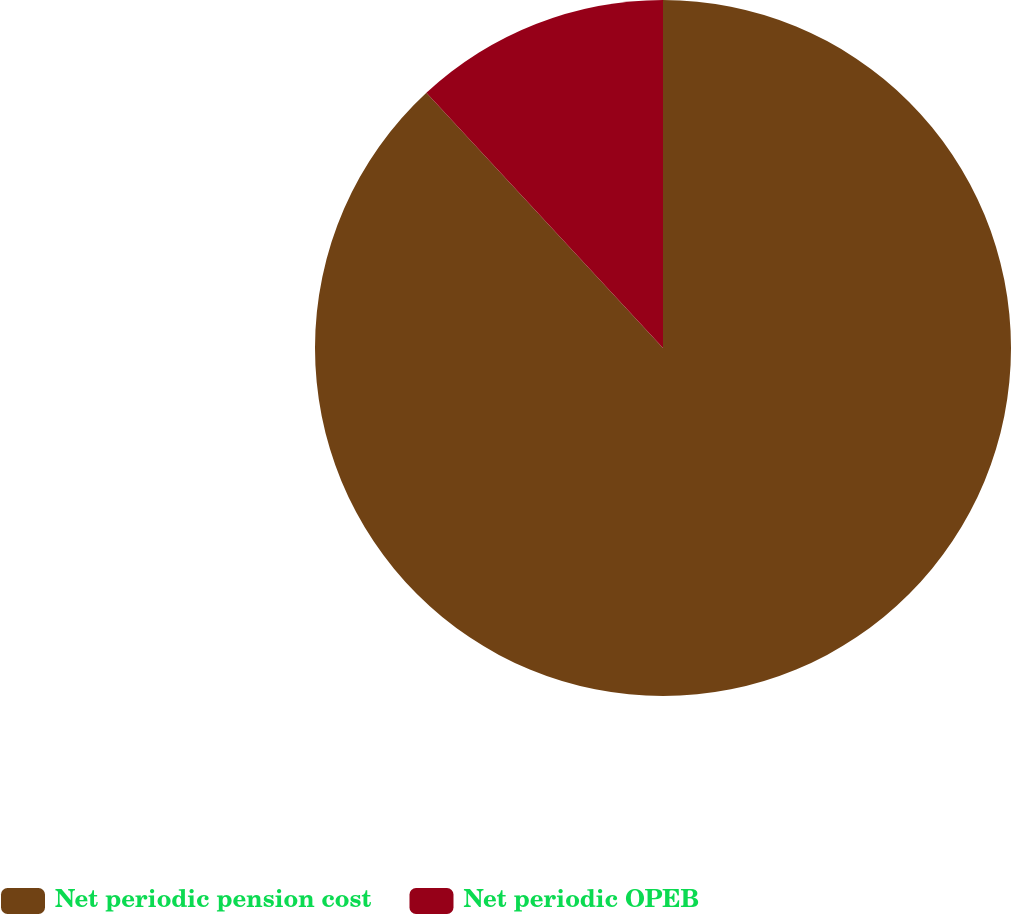Convert chart to OTSL. <chart><loc_0><loc_0><loc_500><loc_500><pie_chart><fcel>Net periodic pension cost<fcel>Net periodic OPEB<nl><fcel>88.1%<fcel>11.9%<nl></chart> 